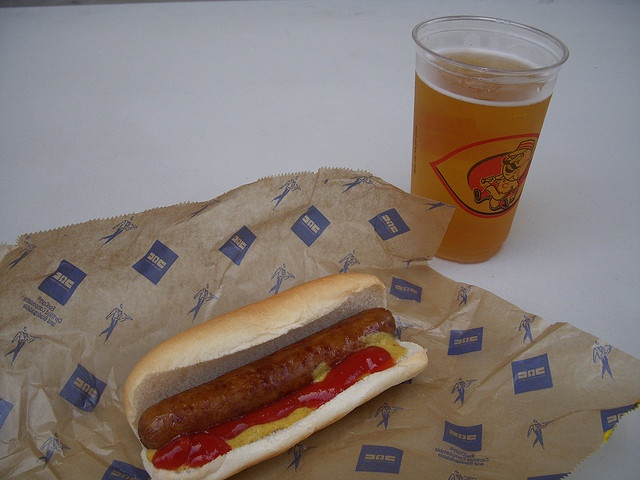Describe the objects in this image and their specific colors. I can see hot dog in black, maroon, darkgray, tan, and gray tones and cup in black, maroon, darkgray, and gray tones in this image. 